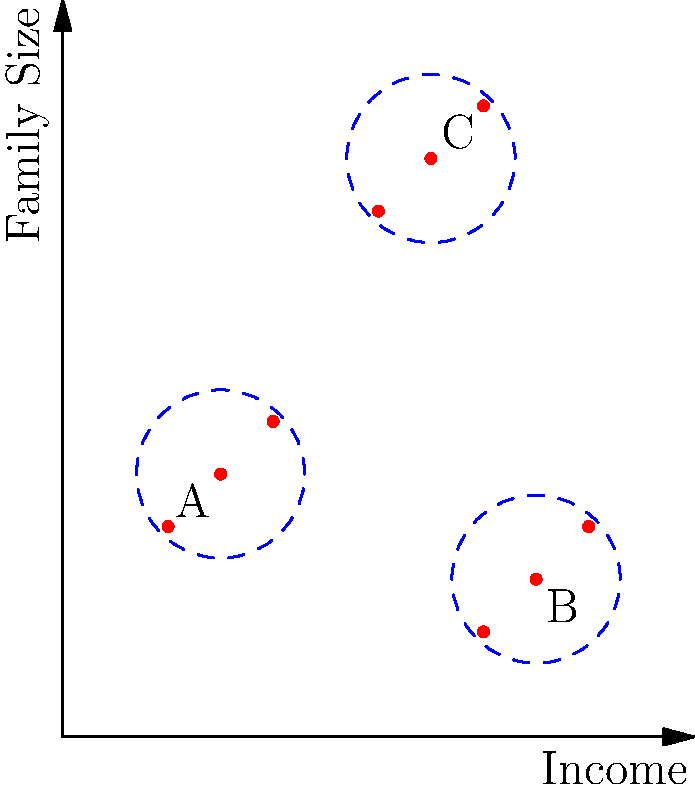Based on the 2D representation of multidimensional data points shown in the graph, which cluster would likely require the most comprehensive family support services, considering both income level and family size? To determine which cluster would likely require the most comprehensive family support services, we need to analyze the data points in each cluster based on their position in the 2D space representing income and family size:

1. Identify the clusters:
   Cluster A: Lower income, smaller family size
   Cluster B: Higher income, smaller family size
   Cluster C: Medium income, larger family size

2. Analyze each cluster:
   Cluster A: 
   - Low income (around 1-2 on the x-axis)
   - Small family size (around 2-3 on the y-axis)
   - May need financial assistance and basic support services

   Cluster B:
   - Higher income (around 4-5 on the x-axis)
   - Small family size (around 1-2 on the y-axis)
   - Likely requires minimal support services due to higher income and smaller family size

   Cluster C:
   - Medium income (around 3-4 on the x-axis)
   - Large family size (around 5-6 on the y-axis)
   - May need a wide range of services due to the combination of moderate income and large family size

3. Consider the implications:
   - Larger families generally require more resources and diverse services
   - Lower income families typically need more financial assistance
   - The combination of family size and income level affects the complexity of needs

4. Conclusion:
   Cluster C is likely to require the most comprehensive family support services because:
   - It represents larger families, which often have more complex needs
   - The income level is moderate, indicating potential financial strain when supporting a larger family
   - The combination of these factors suggests a need for diverse services such as childcare, education support, healthcare, and possibly financial counseling
Answer: Cluster C 